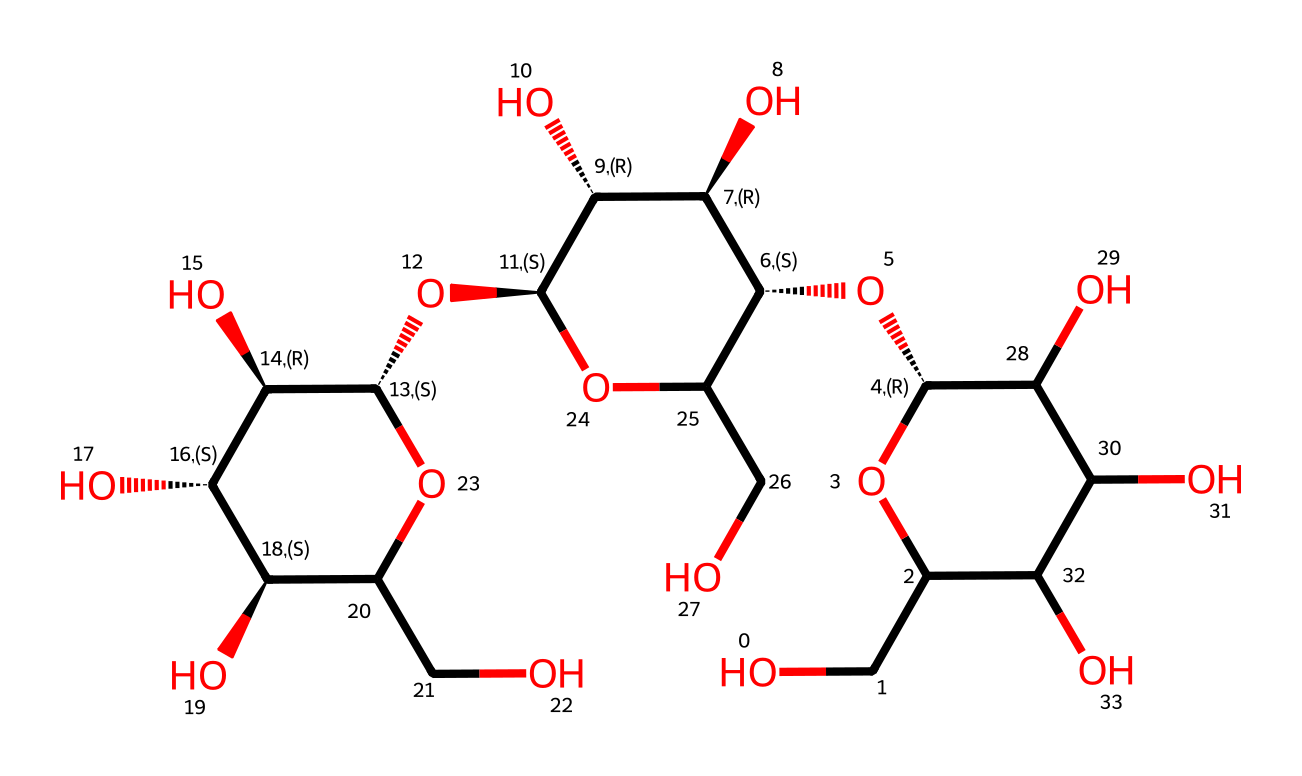What is the main type of chemical functional group present in cellulose? Cellulose is a polysaccharide consisting of multiple hydroxyl (-OH) groups, which are characteristic of carbohydrates. This can be confirmed by observing the structure where -OH groups appear attached to the carbon skeleton.
Answer: hydroxyl How many rings are present in the molecular structure of cellulose? By analyzing the SMILES representation, we can identify three separate ring structures created by cyclic forms of glucose units. Each cycle corresponds to a glucose monomer, indicating that there are three rings.
Answer: three What is the degree of polymerization for the cellulose represented in this structure? The degree of polymerization can be determined by counting the number of glucose units connected in the structure. In this case, there are several interconnected glucose rings signifying a long chain typical of cellulose, which consists of multiple glucose units.
Answer: approximately ten What type of bond connects the glucose units in cellulose? The structure reveals that the glucose units are linked through glycosidic bonds, which are formed by the condensation reaction between hydroxyl groups on adjacent glucose molecules, resulting in ether-like linkages.
Answer: glycosidic bond How does the arrangement of hydroxyl groups in cellulose contribute to its properties? The multiple hydroxyl groups provide hydrogen bonding capabilities, resulting in cellulose's high tensile strength and its insolubility in water. This is evident in the structural organization where these groups are positioned to allow extensive intermolecular hydrogen bonding.
Answer: hydrogen bonding 